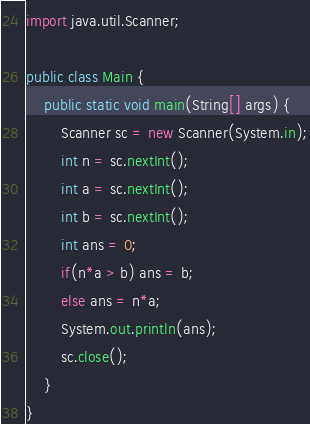Convert code to text. <code><loc_0><loc_0><loc_500><loc_500><_Java_>import java.util.Scanner;

public class Main {
    public static void main(String[] args) {
        Scanner sc = new Scanner(System.in);
        int n = sc.nextInt();
        int a = sc.nextInt();
        int b = sc.nextInt();
        int ans = 0;
        if(n*a > b) ans = b;
        else ans = n*a;
        System.out.println(ans);
        sc.close();
    }
}
</code> 